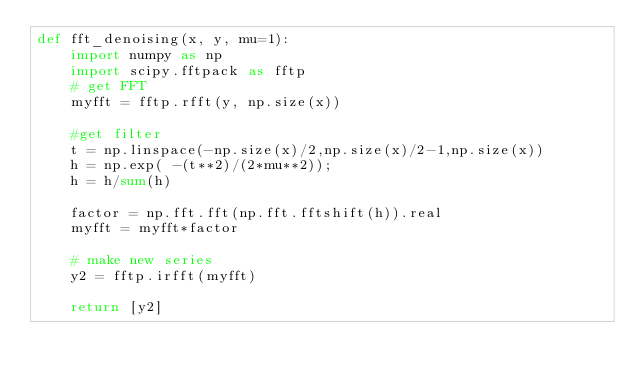Convert code to text. <code><loc_0><loc_0><loc_500><loc_500><_Python_>def fft_denoising(x, y, mu=1):
    import numpy as np
    import scipy.fftpack as fftp
    # get FFT
    myfft = fftp.rfft(y, np.size(x))
    
    #get filter
    t = np.linspace(-np.size(x)/2,np.size(x)/2-1,np.size(x))
    h = np.exp( -(t**2)/(2*mu**2));
    h = h/sum(h)
    
    factor = np.fft.fft(np.fft.fftshift(h)).real
    myfft = myfft*factor

    # make new series
    y2 = fftp.irfft(myfft)

    return [y2]</code> 